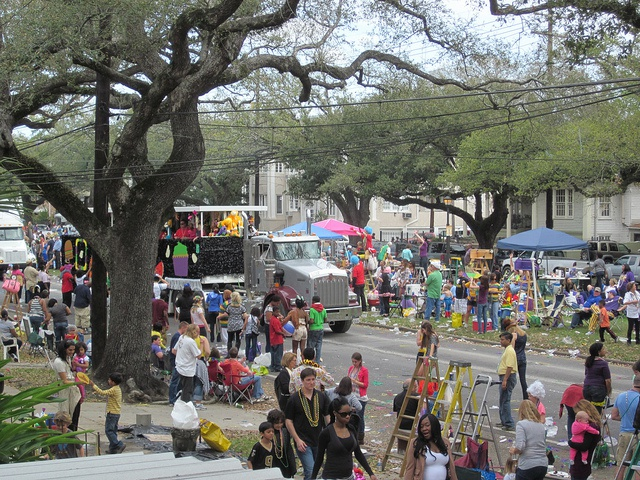Describe the objects in this image and their specific colors. I can see people in gray, black, and darkgray tones, truck in gray, black, darkgray, and lightgray tones, people in gray, black, and olive tones, people in gray and black tones, and people in gray, black, darkgray, and lightgray tones in this image. 